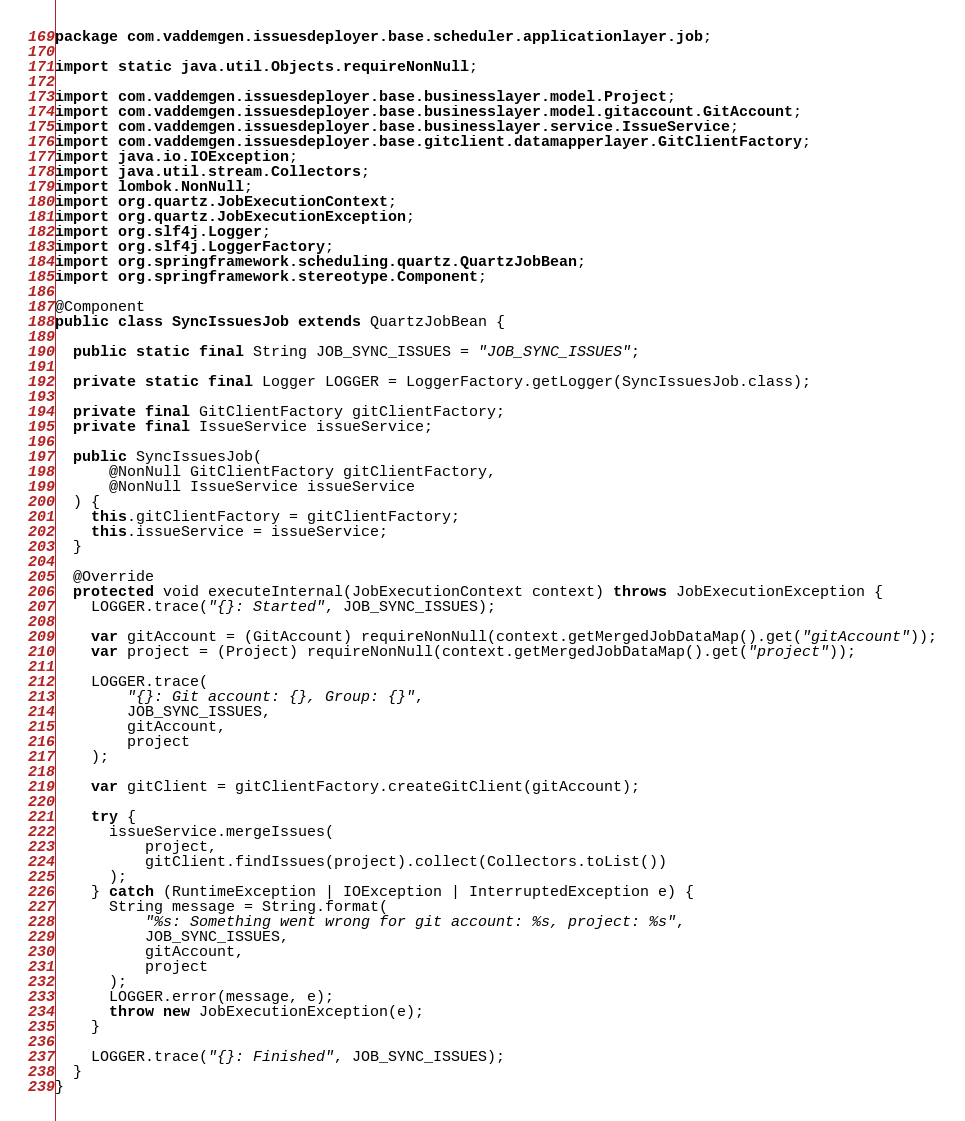<code> <loc_0><loc_0><loc_500><loc_500><_Java_>package com.vaddemgen.issuesdeployer.base.scheduler.applicationlayer.job;

import static java.util.Objects.requireNonNull;

import com.vaddemgen.issuesdeployer.base.businesslayer.model.Project;
import com.vaddemgen.issuesdeployer.base.businesslayer.model.gitaccount.GitAccount;
import com.vaddemgen.issuesdeployer.base.businesslayer.service.IssueService;
import com.vaddemgen.issuesdeployer.base.gitclient.datamapperlayer.GitClientFactory;
import java.io.IOException;
import java.util.stream.Collectors;
import lombok.NonNull;
import org.quartz.JobExecutionContext;
import org.quartz.JobExecutionException;
import org.slf4j.Logger;
import org.slf4j.LoggerFactory;
import org.springframework.scheduling.quartz.QuartzJobBean;
import org.springframework.stereotype.Component;

@Component
public class SyncIssuesJob extends QuartzJobBean {

  public static final String JOB_SYNC_ISSUES = "JOB_SYNC_ISSUES";

  private static final Logger LOGGER = LoggerFactory.getLogger(SyncIssuesJob.class);

  private final GitClientFactory gitClientFactory;
  private final IssueService issueService;

  public SyncIssuesJob(
      @NonNull GitClientFactory gitClientFactory,
      @NonNull IssueService issueService
  ) {
    this.gitClientFactory = gitClientFactory;
    this.issueService = issueService;
  }

  @Override
  protected void executeInternal(JobExecutionContext context) throws JobExecutionException {
    LOGGER.trace("{}: Started", JOB_SYNC_ISSUES);

    var gitAccount = (GitAccount) requireNonNull(context.getMergedJobDataMap().get("gitAccount"));
    var project = (Project) requireNonNull(context.getMergedJobDataMap().get("project"));

    LOGGER.trace(
        "{}: Git account: {}, Group: {}",
        JOB_SYNC_ISSUES,
        gitAccount,
        project
    );

    var gitClient = gitClientFactory.createGitClient(gitAccount);

    try {
      issueService.mergeIssues(
          project,
          gitClient.findIssues(project).collect(Collectors.toList())
      );
    } catch (RuntimeException | IOException | InterruptedException e) {
      String message = String.format(
          "%s: Something went wrong for git account: %s, project: %s",
          JOB_SYNC_ISSUES,
          gitAccount,
          project
      );
      LOGGER.error(message, e);
      throw new JobExecutionException(e);
    }

    LOGGER.trace("{}: Finished", JOB_SYNC_ISSUES);
  }
}
</code> 